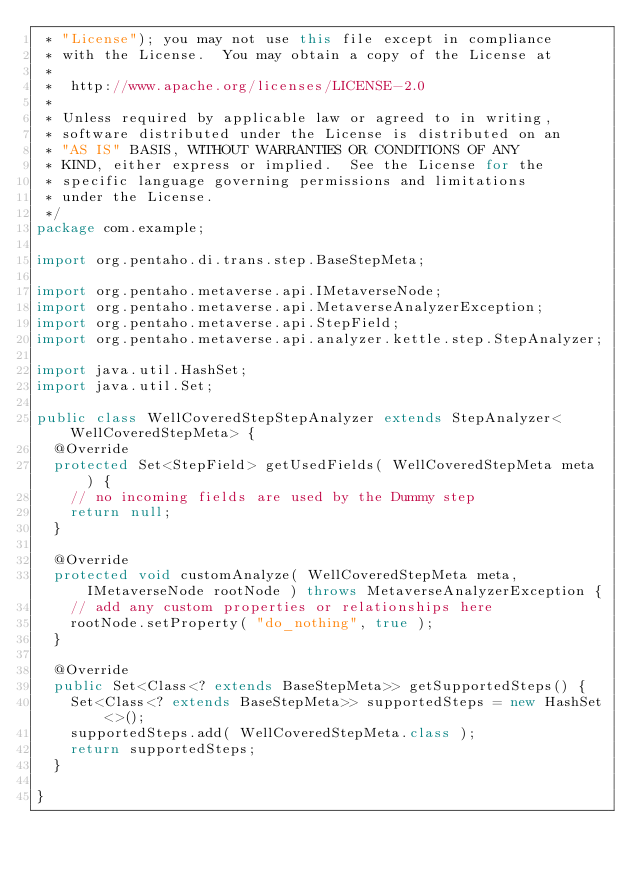Convert code to text. <code><loc_0><loc_0><loc_500><loc_500><_Java_> * "License"); you may not use this file except in compliance
 * with the License.  You may obtain a copy of the License at
 *
 *  http://www.apache.org/licenses/LICENSE-2.0
 *
 * Unless required by applicable law or agreed to in writing,
 * software distributed under the License is distributed on an
 * "AS IS" BASIS, WITHOUT WARRANTIES OR CONDITIONS OF ANY
 * KIND, either express or implied.  See the License for the
 * specific language governing permissions and limitations
 * under the License.
 */
package com.example;

import org.pentaho.di.trans.step.BaseStepMeta;

import org.pentaho.metaverse.api.IMetaverseNode;
import org.pentaho.metaverse.api.MetaverseAnalyzerException;
import org.pentaho.metaverse.api.StepField;
import org.pentaho.metaverse.api.analyzer.kettle.step.StepAnalyzer;

import java.util.HashSet;
import java.util.Set;

public class WellCoveredStepStepAnalyzer extends StepAnalyzer<WellCoveredStepMeta> {
  @Override
  protected Set<StepField> getUsedFields( WellCoveredStepMeta meta ) {
    // no incoming fields are used by the Dummy step
    return null;
  }

  @Override
  protected void customAnalyze( WellCoveredStepMeta meta, IMetaverseNode rootNode ) throws MetaverseAnalyzerException {
    // add any custom properties or relationships here
    rootNode.setProperty( "do_nothing", true );
  }

  @Override
  public Set<Class<? extends BaseStepMeta>> getSupportedSteps() {
    Set<Class<? extends BaseStepMeta>> supportedSteps = new HashSet<>();
    supportedSteps.add( WellCoveredStepMeta.class );
    return supportedSteps;
  }

}
</code> 